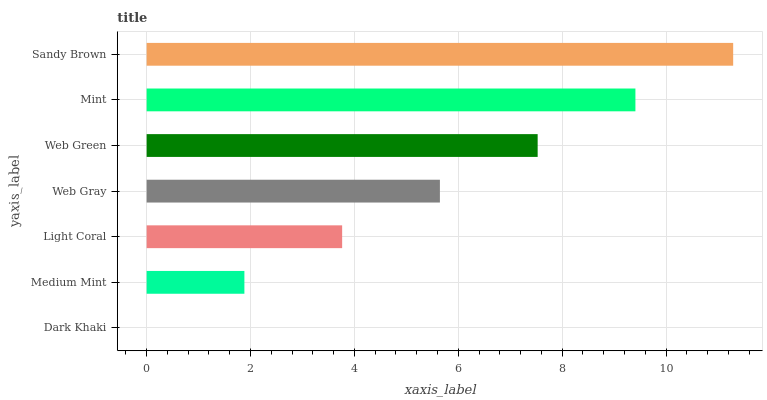Is Dark Khaki the minimum?
Answer yes or no. Yes. Is Sandy Brown the maximum?
Answer yes or no. Yes. Is Medium Mint the minimum?
Answer yes or no. No. Is Medium Mint the maximum?
Answer yes or no. No. Is Medium Mint greater than Dark Khaki?
Answer yes or no. Yes. Is Dark Khaki less than Medium Mint?
Answer yes or no. Yes. Is Dark Khaki greater than Medium Mint?
Answer yes or no. No. Is Medium Mint less than Dark Khaki?
Answer yes or no. No. Is Web Gray the high median?
Answer yes or no. Yes. Is Web Gray the low median?
Answer yes or no. Yes. Is Light Coral the high median?
Answer yes or no. No. Is Web Green the low median?
Answer yes or no. No. 